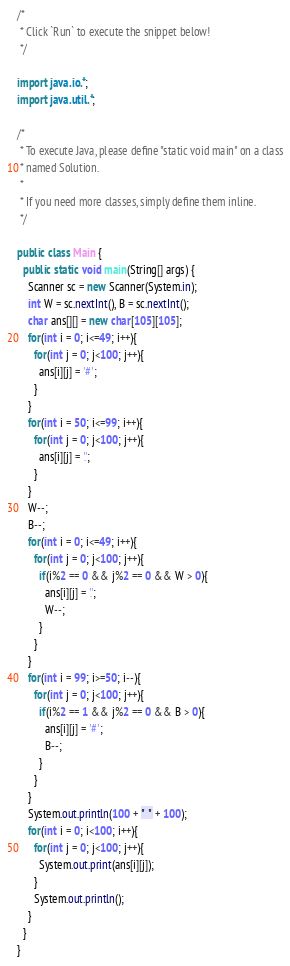<code> <loc_0><loc_0><loc_500><loc_500><_Java_>/*
 * Click `Run` to execute the snippet below!
 */
 
import java.io.*;
import java.util.*;

/*
 * To execute Java, please define "static void main" on a class
 * named Solution.
 *
 * If you need more classes, simply define them inline. 
 */

public class Main {
  public static void main(String[] args) {
    Scanner sc = new Scanner(System.in);
    int W = sc.nextInt(), B = sc.nextInt();
    char ans[][] = new char[105][105];
    for(int i = 0; i<=49; i++){
      for(int j = 0; j<100; j++){
        ans[i][j] = '#';
      }
    }
    for(int i = 50; i<=99; i++){
      for(int j = 0; j<100; j++){
        ans[i][j] = '.'; 
      }
    }
    W--;
    B--;
    for(int i = 0; i<=49; i++){
      for(int j = 0; j<100; j++){
        if(i%2 == 0 && j%2 == 0 && W > 0){
          ans[i][j] = '.';
          W--;
        }
      }
    }
    for(int i = 99; i>=50; i--){
      for(int j = 0; j<100; j++){
        if(i%2 == 1 && j%2 == 0 && B > 0){
          ans[i][j] = '#';
          B--;
        }
      }
    }
    System.out.println(100 + " " + 100);
    for(int i = 0; i<100; i++){
      for(int j = 0; j<100; j++){
        System.out.print(ans[i][j]); 
      }
      System.out.println();
    }
  }
}
</code> 